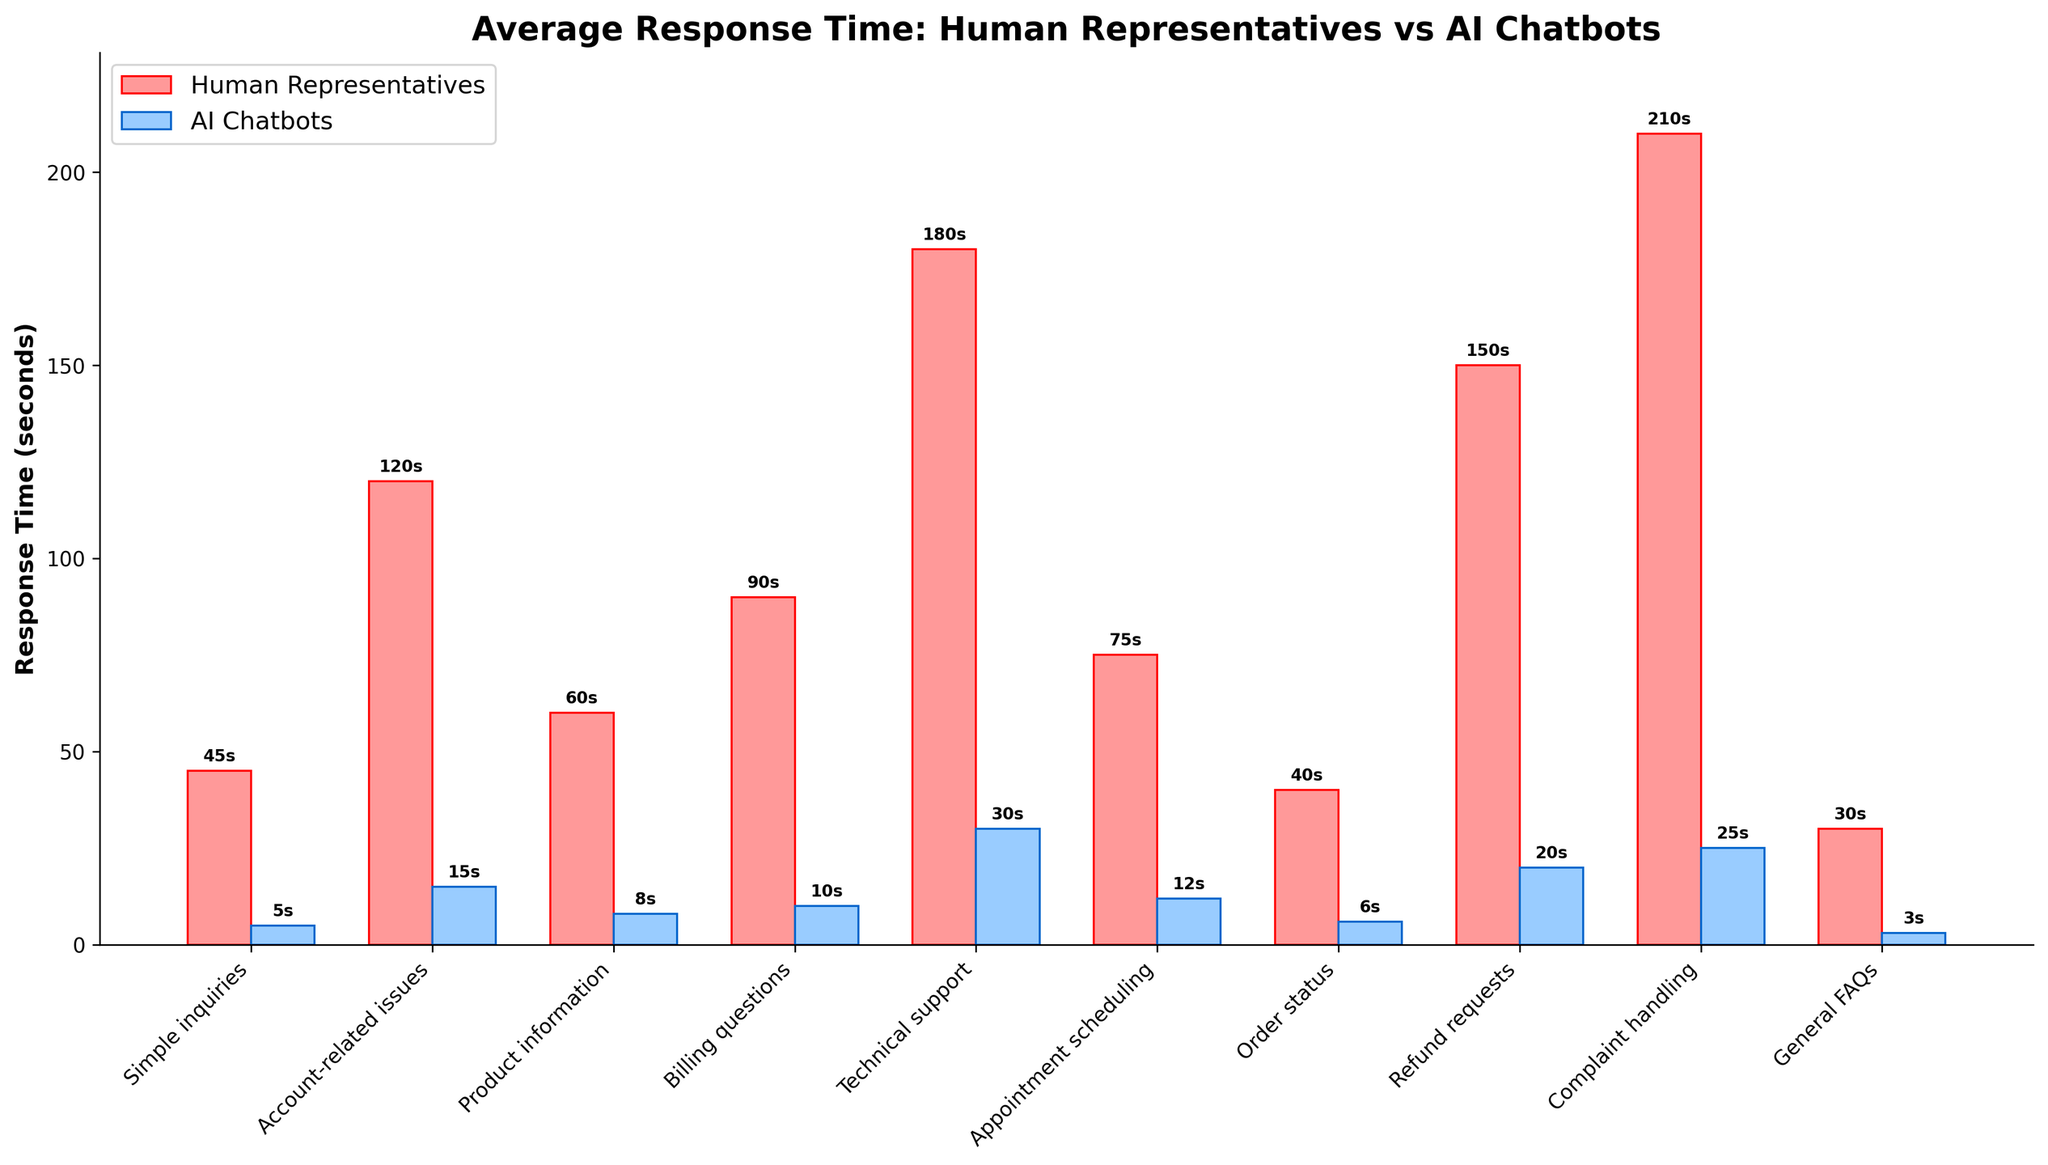Which type of inquiry has the smallest difference in response time between human representatives and AI chatbots? To find the smallest difference in response time, we subtract the AI response time from the human response time for each category: Simple inquiries (40s), Account-related issues (105s), Product information (52s), Booking questions (80s), Technical support (150s), Appointment scheduling (63s), Order status (34s), Refund requests (130s), Complaint handling (185s), General FAQs (27s). The smallest difference is 27s for General FAQs.
Answer: General FAQs Which type of inquiry do human representatives take the longest to respond to? By checking the height of the bars for human representatives, 'Complaint handling' has the highest bar at 210s.
Answer: Complaint handling How many types of inquiries do AI chatbots respond to in under 10 seconds? By looking at the heights of the blue bars, AI chatbots respond in 5s (Simple inquiries), 8s (Product information), 6s (Order status), and 3s (General FAQs). There are four types of inquiries with response times under 10s.
Answer: Four What’s the average response time difference between human representatives and AI chatbots across all categories? Calculate the difference for each category: 40s, 105s, 52s, 80s, 150s, 63s, 34s, 130s, 185s, 27s. Sum these differences (866s) and divide by the number of categories (10). Average difference = 866 / 10 = 86.6s.
Answer: 86.6s Is there any type of inquiry where AI chatbots take longer to respond than human representatives? By comparing the heights of the blue and red bars, AI chatbots have lower response times across all categories, so there are no instances where AI chatbots take longer.
Answer: No Which type of inquiry has the largest difference in response time between human representatives and AI chatbots? Subtract AI response time from human response time for each category: Simple inquiries (40s), Account-related issues (105s), Product information (52s), Booking questions (80s), Technical support (150s), Appointment scheduling (63s), Order status (34s), Refund requests (130s), Complaint handling (185s), General FAQs (27s). The largest difference is 185s for Complaint handling.
Answer: Complaint handling For which type of inquiry do AI chatbots provide their fastest responses? By looking at the blue bars, 'General FAQs' has the shortest bar at 3s.
Answer: General FAQs Which four categories have a response time of human representatives over 100 seconds? By checking the height of the red bars, the categories are 'Account-related issues' (120s), 'Technical support' (180s), 'Refund requests' (150s), and 'Complaint handling' (210s).
Answer: Account-related issues, Technical support, Refund requests, Complaint handling What is the average response time for AI chatbots across all categories? Sum the AI response times: 5s, 15s, 8s, 10s, 30s, 12s, 6s, 20s, 25s, 3s. Total = 134s. Average = 134s / 10 = 13.4s.
Answer: 13.4s 